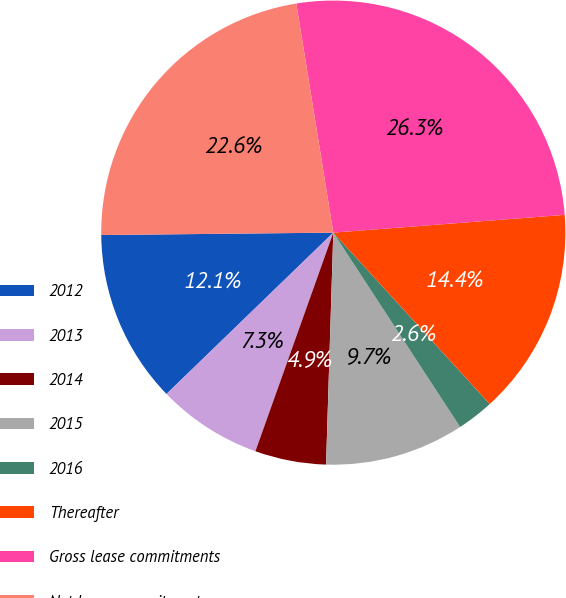<chart> <loc_0><loc_0><loc_500><loc_500><pie_chart><fcel>2012<fcel>2013<fcel>2014<fcel>2015<fcel>2016<fcel>Thereafter<fcel>Gross lease commitments<fcel>Net lease commitments<nl><fcel>12.07%<fcel>7.32%<fcel>4.95%<fcel>9.7%<fcel>2.57%<fcel>14.45%<fcel>26.33%<fcel>22.62%<nl></chart> 